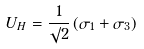<formula> <loc_0><loc_0><loc_500><loc_500>U _ { H } = \frac { 1 } { \surd 2 } \left ( \sigma _ { 1 } + \sigma _ { 3 } \right )</formula> 